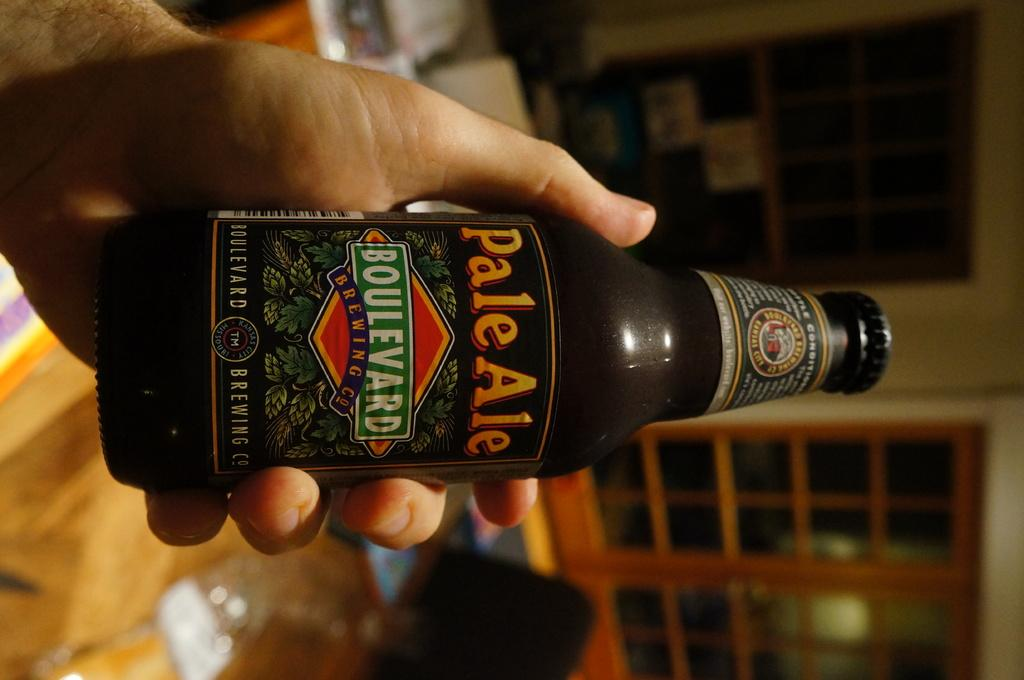<image>
Describe the image concisely. A bottle of Pale Ale is being held in front of a red door 